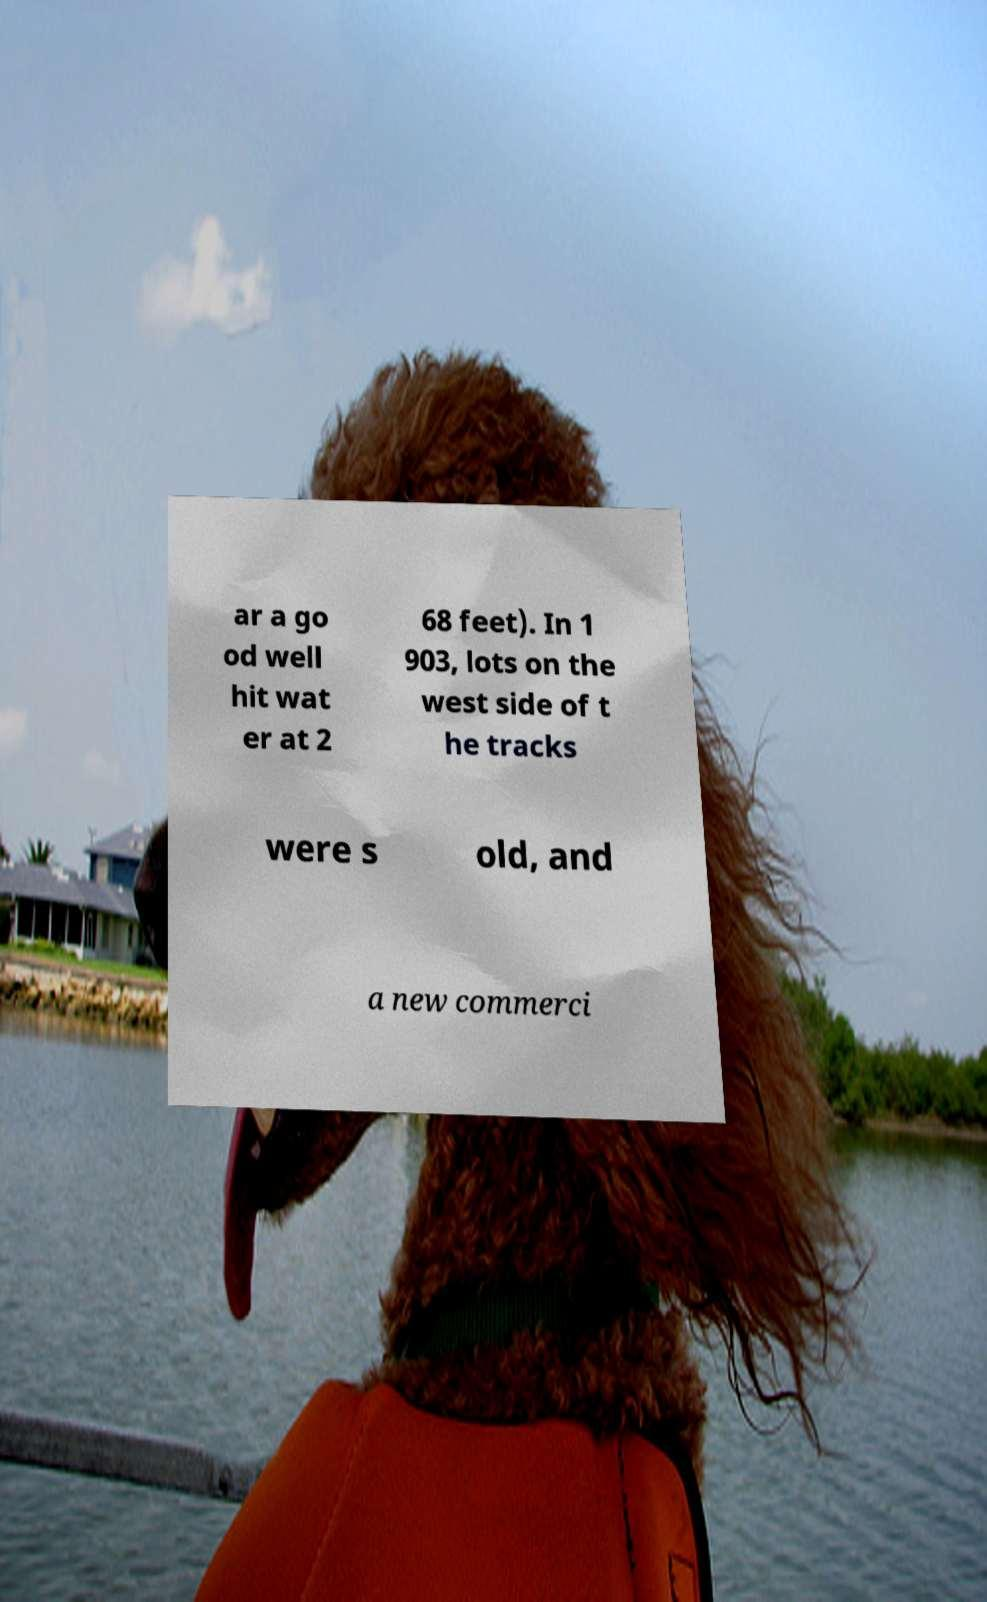I need the written content from this picture converted into text. Can you do that? ar a go od well hit wat er at 2 68 feet). In 1 903, lots on the west side of t he tracks were s old, and a new commerci 